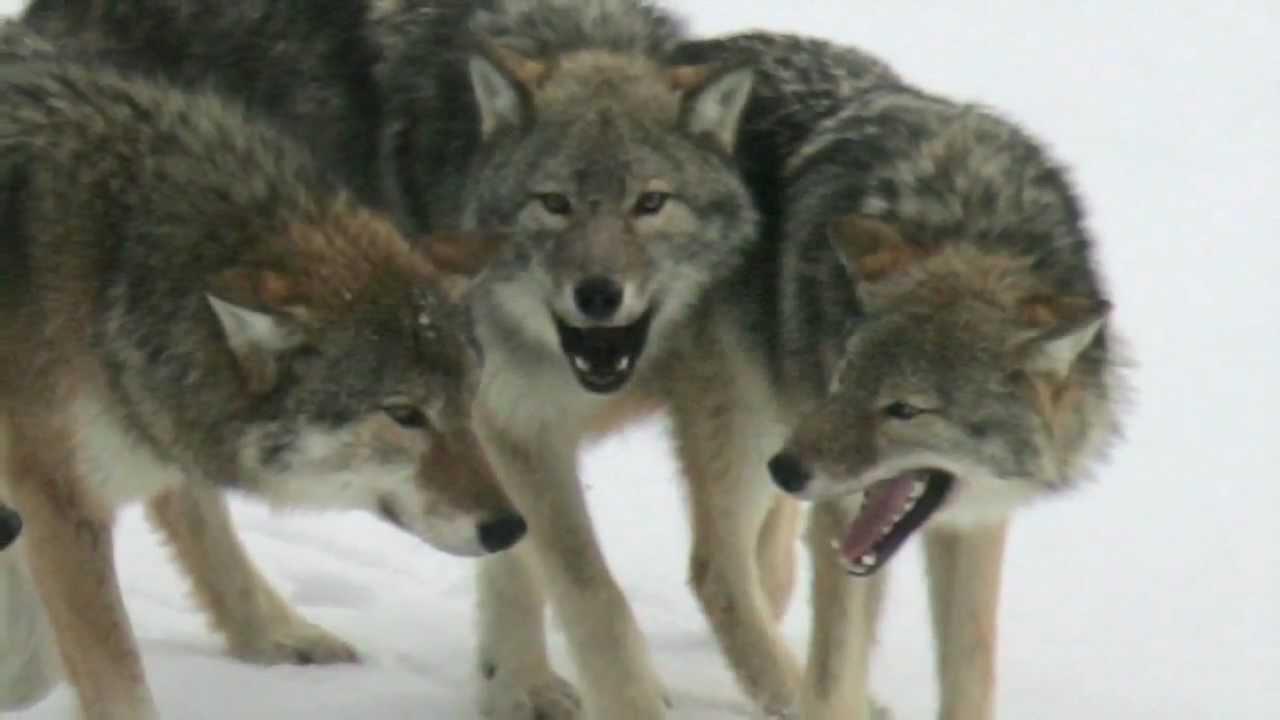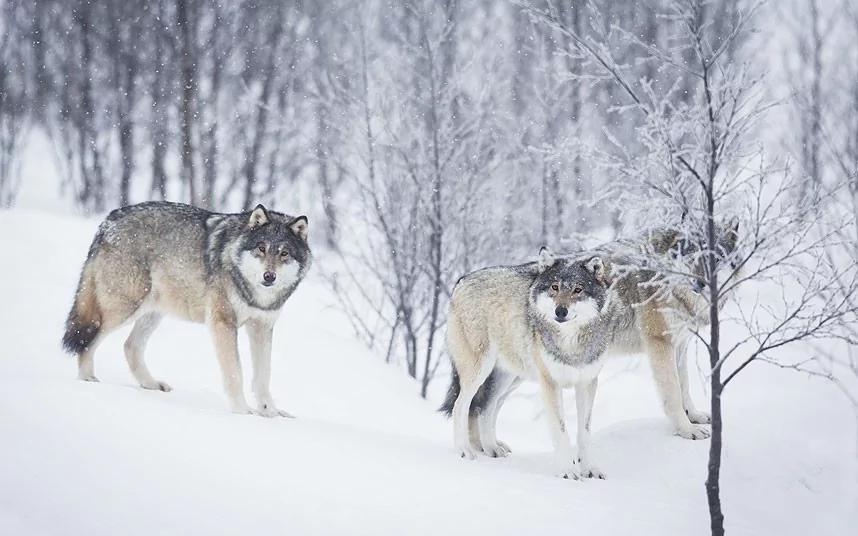The first image is the image on the left, the second image is the image on the right. Given the left and right images, does the statement "There are exactly three wolves standing next to each-other in the image on the left." hold true? Answer yes or no. Yes. The first image is the image on the left, the second image is the image on the right. Given the left and right images, does the statement "An image shows a row of three wolves with heads that are not raised high, and two of the wolves have open mouths." hold true? Answer yes or no. Yes. 